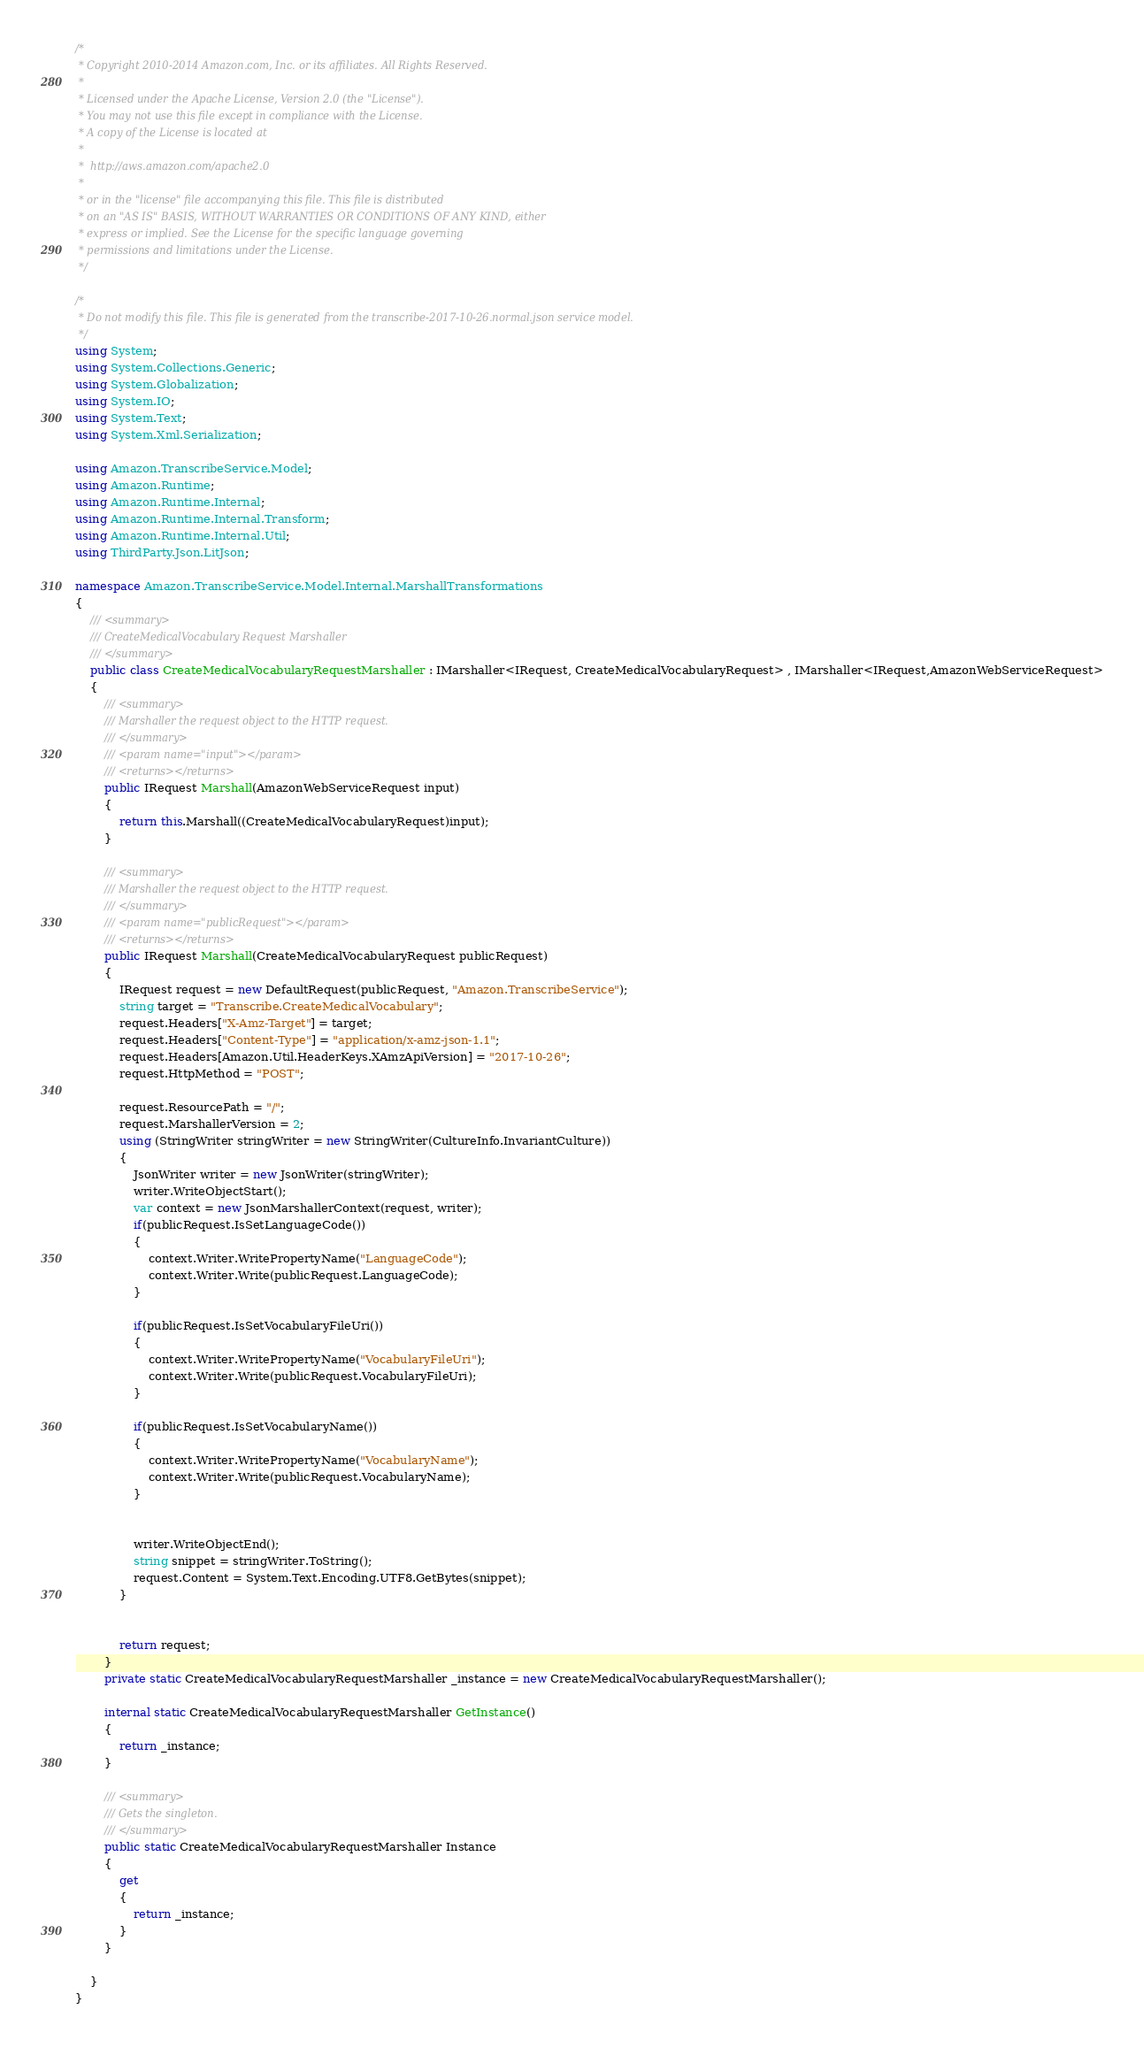<code> <loc_0><loc_0><loc_500><loc_500><_C#_>/*
 * Copyright 2010-2014 Amazon.com, Inc. or its affiliates. All Rights Reserved.
 * 
 * Licensed under the Apache License, Version 2.0 (the "License").
 * You may not use this file except in compliance with the License.
 * A copy of the License is located at
 * 
 *  http://aws.amazon.com/apache2.0
 * 
 * or in the "license" file accompanying this file. This file is distributed
 * on an "AS IS" BASIS, WITHOUT WARRANTIES OR CONDITIONS OF ANY KIND, either
 * express or implied. See the License for the specific language governing
 * permissions and limitations under the License.
 */

/*
 * Do not modify this file. This file is generated from the transcribe-2017-10-26.normal.json service model.
 */
using System;
using System.Collections.Generic;
using System.Globalization;
using System.IO;
using System.Text;
using System.Xml.Serialization;

using Amazon.TranscribeService.Model;
using Amazon.Runtime;
using Amazon.Runtime.Internal;
using Amazon.Runtime.Internal.Transform;
using Amazon.Runtime.Internal.Util;
using ThirdParty.Json.LitJson;

namespace Amazon.TranscribeService.Model.Internal.MarshallTransformations
{
    /// <summary>
    /// CreateMedicalVocabulary Request Marshaller
    /// </summary>       
    public class CreateMedicalVocabularyRequestMarshaller : IMarshaller<IRequest, CreateMedicalVocabularyRequest> , IMarshaller<IRequest,AmazonWebServiceRequest>
    {
        /// <summary>
        /// Marshaller the request object to the HTTP request.
        /// </summary>  
        /// <param name="input"></param>
        /// <returns></returns>
        public IRequest Marshall(AmazonWebServiceRequest input)
        {
            return this.Marshall((CreateMedicalVocabularyRequest)input);
        }

        /// <summary>
        /// Marshaller the request object to the HTTP request.
        /// </summary>  
        /// <param name="publicRequest"></param>
        /// <returns></returns>
        public IRequest Marshall(CreateMedicalVocabularyRequest publicRequest)
        {
            IRequest request = new DefaultRequest(publicRequest, "Amazon.TranscribeService");
            string target = "Transcribe.CreateMedicalVocabulary";
            request.Headers["X-Amz-Target"] = target;
            request.Headers["Content-Type"] = "application/x-amz-json-1.1";
            request.Headers[Amazon.Util.HeaderKeys.XAmzApiVersion] = "2017-10-26";            
            request.HttpMethod = "POST";

            request.ResourcePath = "/";
            request.MarshallerVersion = 2;
            using (StringWriter stringWriter = new StringWriter(CultureInfo.InvariantCulture))
            {
                JsonWriter writer = new JsonWriter(stringWriter);
                writer.WriteObjectStart();
                var context = new JsonMarshallerContext(request, writer);
                if(publicRequest.IsSetLanguageCode())
                {
                    context.Writer.WritePropertyName("LanguageCode");
                    context.Writer.Write(publicRequest.LanguageCode);
                }

                if(publicRequest.IsSetVocabularyFileUri())
                {
                    context.Writer.WritePropertyName("VocabularyFileUri");
                    context.Writer.Write(publicRequest.VocabularyFileUri);
                }

                if(publicRequest.IsSetVocabularyName())
                {
                    context.Writer.WritePropertyName("VocabularyName");
                    context.Writer.Write(publicRequest.VocabularyName);
                }

        
                writer.WriteObjectEnd();
                string snippet = stringWriter.ToString();
                request.Content = System.Text.Encoding.UTF8.GetBytes(snippet);
            }


            return request;
        }
        private static CreateMedicalVocabularyRequestMarshaller _instance = new CreateMedicalVocabularyRequestMarshaller();        

        internal static CreateMedicalVocabularyRequestMarshaller GetInstance()
        {
            return _instance;
        }

        /// <summary>
        /// Gets the singleton.
        /// </summary>  
        public static CreateMedicalVocabularyRequestMarshaller Instance
        {
            get
            {
                return _instance;
            }
        }

    }
}</code> 